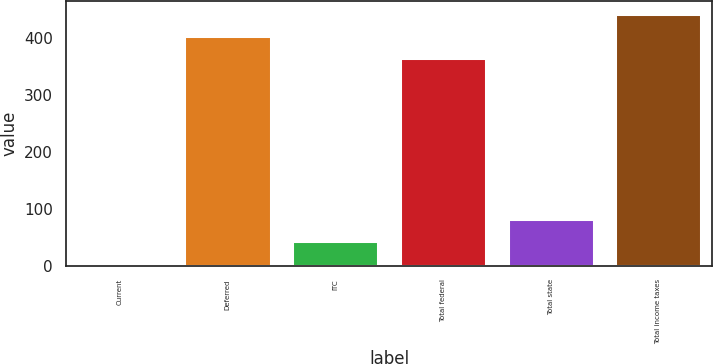<chart> <loc_0><loc_0><loc_500><loc_500><bar_chart><fcel>Current<fcel>Deferred<fcel>ITC<fcel>Total federal<fcel>Total state<fcel>Total income taxes<nl><fcel>4<fcel>403.3<fcel>43.3<fcel>364<fcel>82.6<fcel>442.6<nl></chart> 